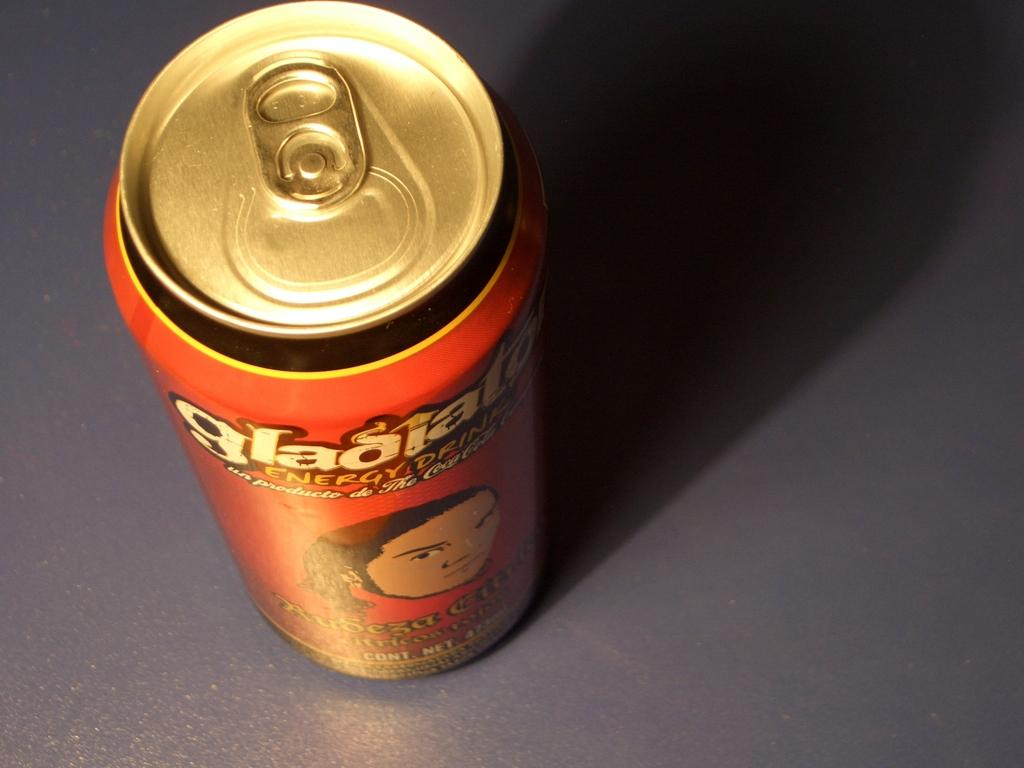<image>
Provide a brief description of the given image. A can of some sort of beverage called Gladiator. 